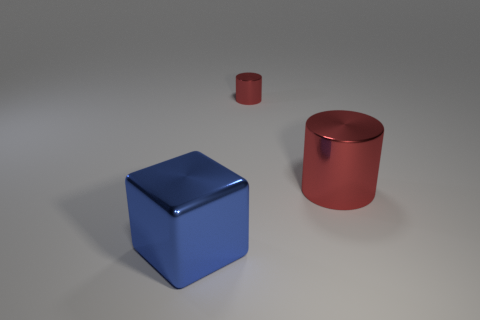How many other things are there of the same shape as the large blue shiny thing?
Ensure brevity in your answer.  0. What number of things are objects that are behind the metal block or blue metal things?
Provide a succinct answer. 3. The red metallic object that is to the left of the big thing right of the big blue block is what shape?
Keep it short and to the point. Cylinder. There is a blue metallic object; does it have the same size as the shiny cylinder that is right of the small red thing?
Your answer should be very brief. Yes. What is the material of the object that is to the left of the tiny red metal cylinder?
Keep it short and to the point. Metal. How many metal things are both in front of the small red metallic cylinder and to the left of the big red metal thing?
Provide a short and direct response. 1. What material is the object that is the same size as the metallic block?
Your answer should be compact. Metal. There is a red metallic cylinder that is in front of the tiny red metal cylinder; is its size the same as the object that is on the left side of the tiny cylinder?
Provide a short and direct response. Yes. There is a big block; are there any large red metal cylinders behind it?
Your answer should be compact. Yes. What color is the metal cylinder to the left of the metallic cylinder that is in front of the tiny red thing?
Provide a short and direct response. Red. 